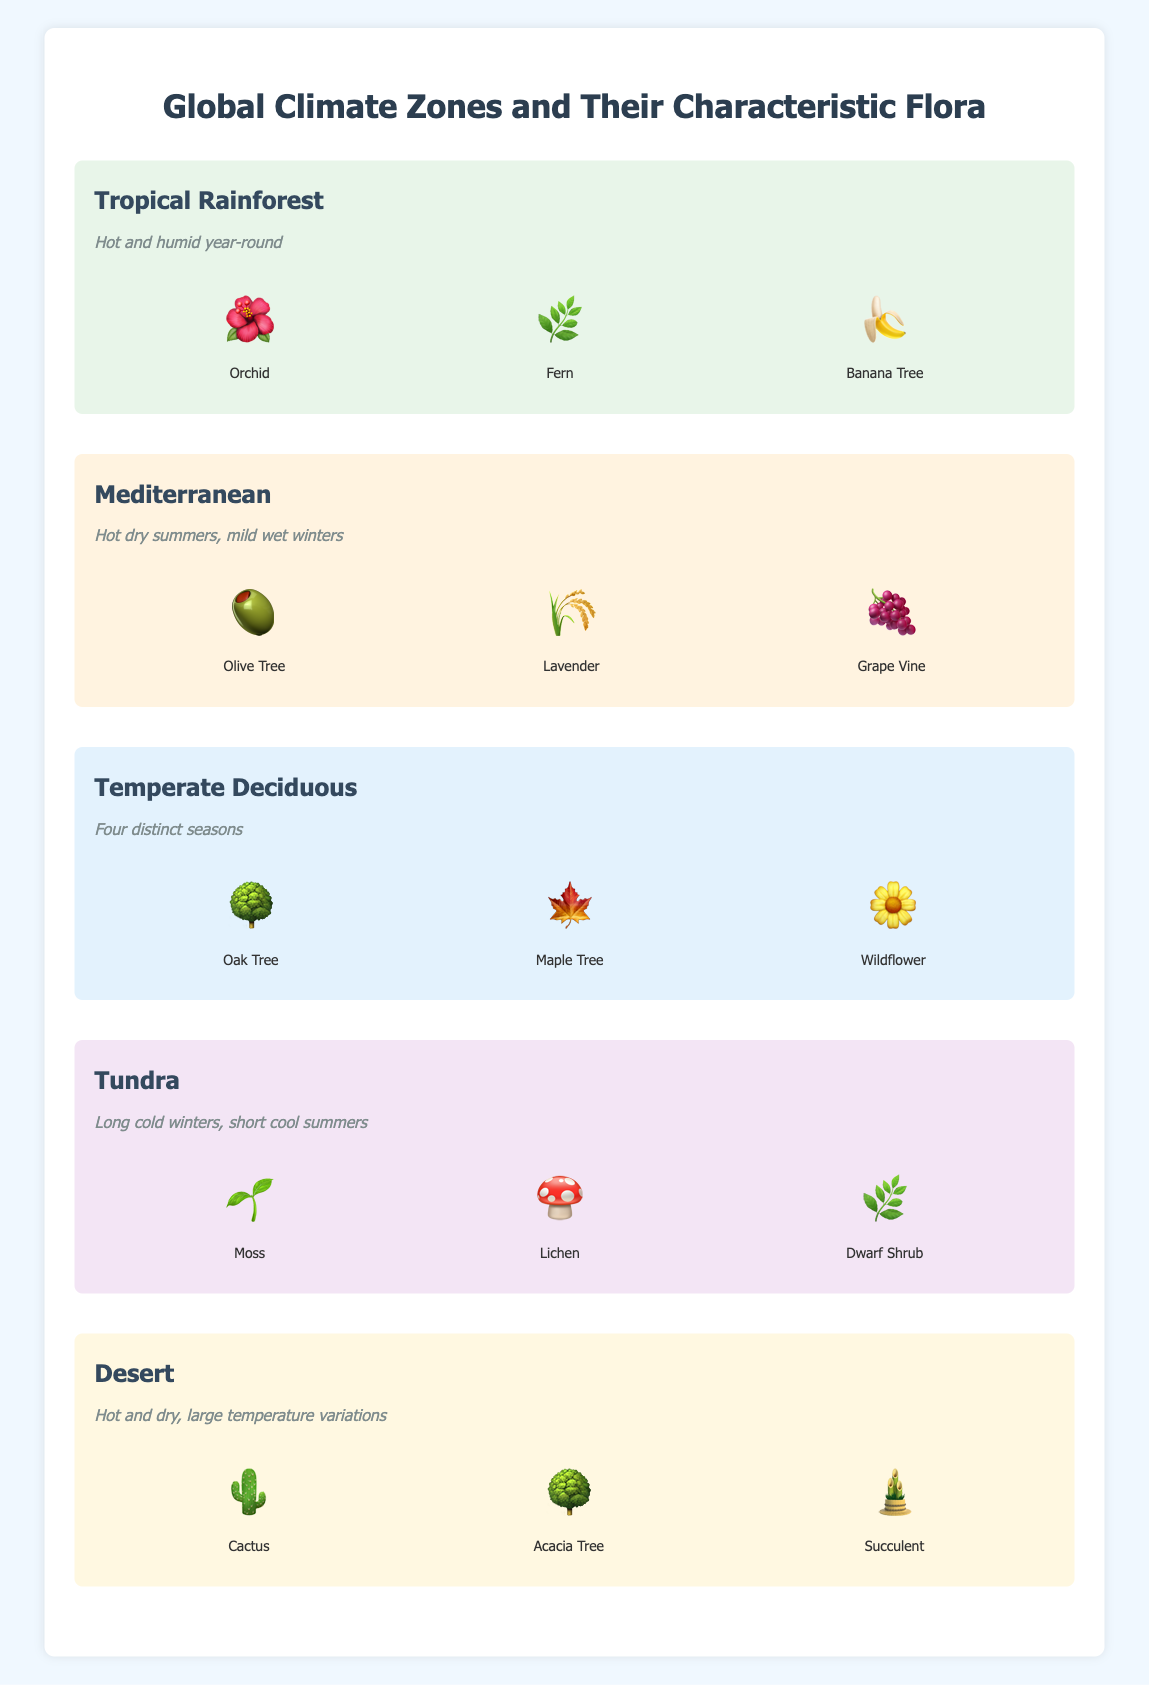What's the characteristic flora found in the Tropical Rainforest zone? Look at the "Tropical Rainforest" section. The flora listed includes Orchid, Fern, and Banana Tree.
Answer: Orchid, Fern, Banana Tree Which climate zone experiences hot dry summers and mild wet winters? Refer to the climate zones' characteristics. Only the "Mediterranean" has "Hot dry summers, mild wet winters".
Answer: Mediterranean What flora is represented by a cactus emoji? Look for the emoji '🌵' within the flora lists. It is found in the "Desert" zone.
Answer: Cactus How many types of flora are listed for each climate zone? Each climate zone lists three types of flora as shown by the flora items for every zone.
Answer: Three What is the characteristic feature of the Temperate Deciduous zone? The Temperate Deciduous zone has the feature “Four distinct seasons” listed under its section.
Answer: Four distinct seasons Which climate zone includes both Oak and Maple Trees? Check the flora lists of climate zones. Both Oak Tree and Maple Tree are listed in the "Temperate Deciduous" zone.
Answer: Temperate Deciduous Compare the typical climate conditions of the Tropical Rainforest and Tundra zones. Summarize the main differences. The Tropical Rainforest is characterized as "Hot and humid year-round". The Tundra is characterized by "Long cold winters, short cool summers". The main difference is that Tropical Rainforest is hot and humid all year, whereas the Tundra is cold with short cool summers.
Answer: Tropical Rainforest is hot and humid year-round, Tundra has long cold winters, short cool summers Which plant, accompanied by its emoji, thrives in a hot and dry climate zone? Referring to the flora for the Desert zone, which has "Hot and dry" characteristics, includes the Cactus (🌵), Acacia Tree (🌳), and Succulent (🎍).
Answer: Cactus (🌵), Acacia Tree (🌳), Succulent (🎍) What type of flora can be found in zones with mild wet winters? Find the climate zone that lists "mild wet winters" in its characteristics, which is "Mediterranean". The flora there includes Olive Tree, Lavender, and Grape Vine.
Answer: Olive Tree, Lavender, Grape Vine 